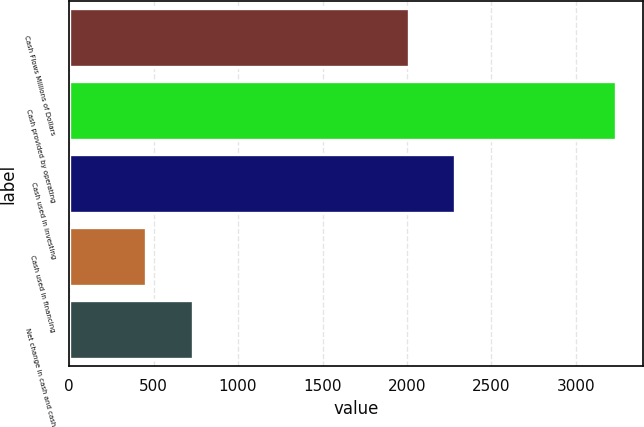<chart> <loc_0><loc_0><loc_500><loc_500><bar_chart><fcel>Cash Flows Millions of Dollars<fcel>Cash provided by operating<fcel>Cash used in investing<fcel>Cash used in financing<fcel>Net change in cash and cash<nl><fcel>2009<fcel>3234<fcel>2286.6<fcel>458<fcel>735.6<nl></chart> 